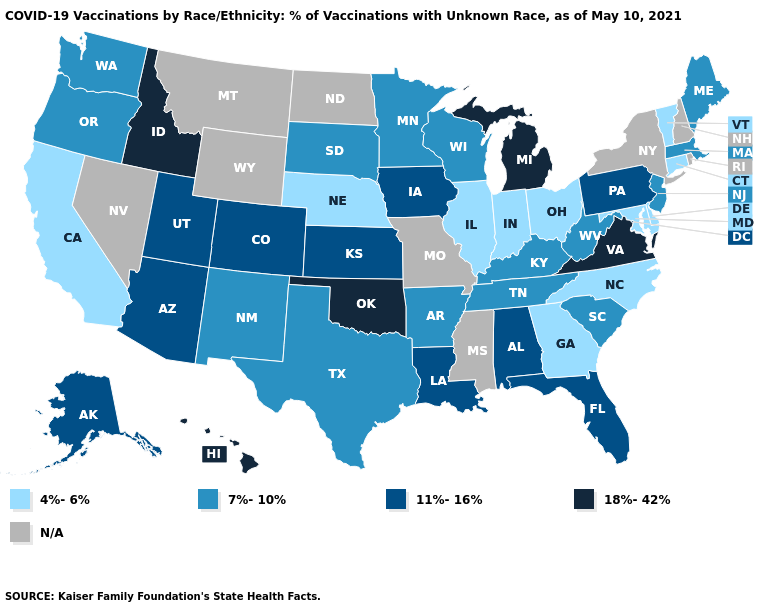What is the value of Florida?
Keep it brief. 11%-16%. Which states have the lowest value in the South?
Write a very short answer. Delaware, Georgia, Maryland, North Carolina. What is the value of Connecticut?
Short answer required. 4%-6%. Among the states that border Montana , which have the highest value?
Write a very short answer. Idaho. Among the states that border Mississippi , which have the highest value?
Write a very short answer. Alabama, Louisiana. Is the legend a continuous bar?
Answer briefly. No. What is the value of Louisiana?
Be succinct. 11%-16%. Name the states that have a value in the range 11%-16%?
Give a very brief answer. Alabama, Alaska, Arizona, Colorado, Florida, Iowa, Kansas, Louisiana, Pennsylvania, Utah. What is the lowest value in the West?
Be succinct. 4%-6%. Name the states that have a value in the range 4%-6%?
Short answer required. California, Connecticut, Delaware, Georgia, Illinois, Indiana, Maryland, Nebraska, North Carolina, Ohio, Vermont. Does Idaho have the highest value in the USA?
Be succinct. Yes. Name the states that have a value in the range N/A?
Keep it brief. Mississippi, Missouri, Montana, Nevada, New Hampshire, New York, North Dakota, Rhode Island, Wyoming. What is the value of Wisconsin?
Write a very short answer. 7%-10%. Name the states that have a value in the range N/A?
Be succinct. Mississippi, Missouri, Montana, Nevada, New Hampshire, New York, North Dakota, Rhode Island, Wyoming. Name the states that have a value in the range 11%-16%?
Give a very brief answer. Alabama, Alaska, Arizona, Colorado, Florida, Iowa, Kansas, Louisiana, Pennsylvania, Utah. 